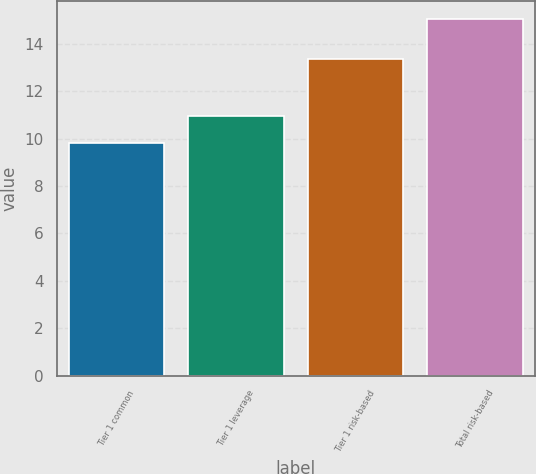Convert chart to OTSL. <chart><loc_0><loc_0><loc_500><loc_500><bar_chart><fcel>Tier 1 common<fcel>Tier 1 leverage<fcel>Tier 1 risk-based<fcel>Total risk-based<nl><fcel>9.8<fcel>10.96<fcel>13.38<fcel>15.05<nl></chart> 